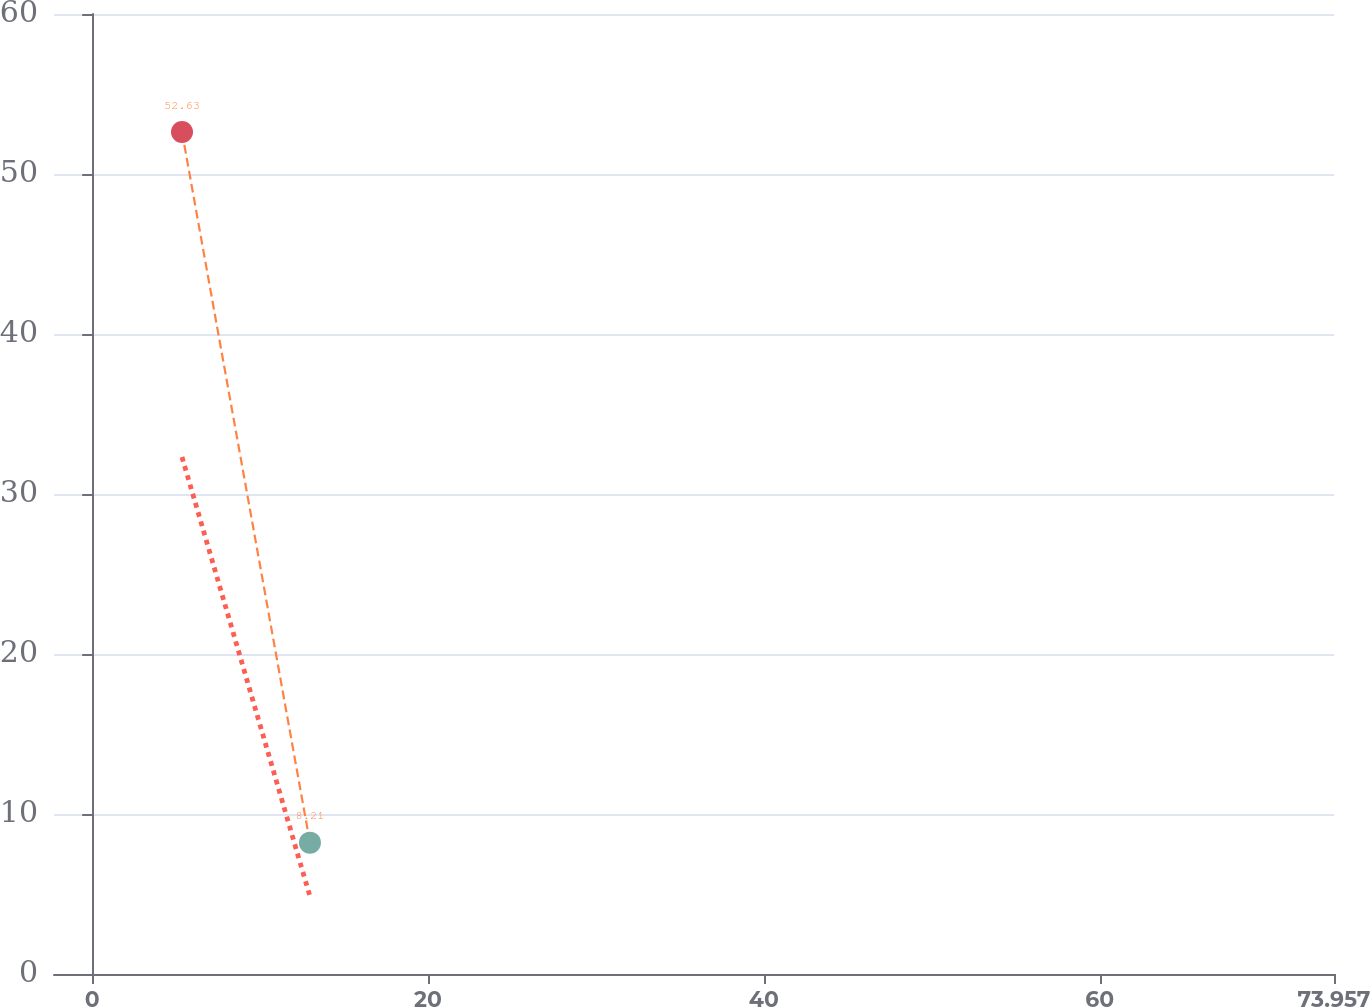Convert chart. <chart><loc_0><loc_0><loc_500><loc_500><line_chart><ecel><fcel>85<fcel>(157)<nl><fcel>5.35<fcel>32.31<fcel>52.63<nl><fcel>12.97<fcel>4.85<fcel>8.21<nl><fcel>81.58<fcel>1.8<fcel>3.28<nl></chart> 